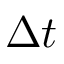<formula> <loc_0><loc_0><loc_500><loc_500>\Delta t</formula> 